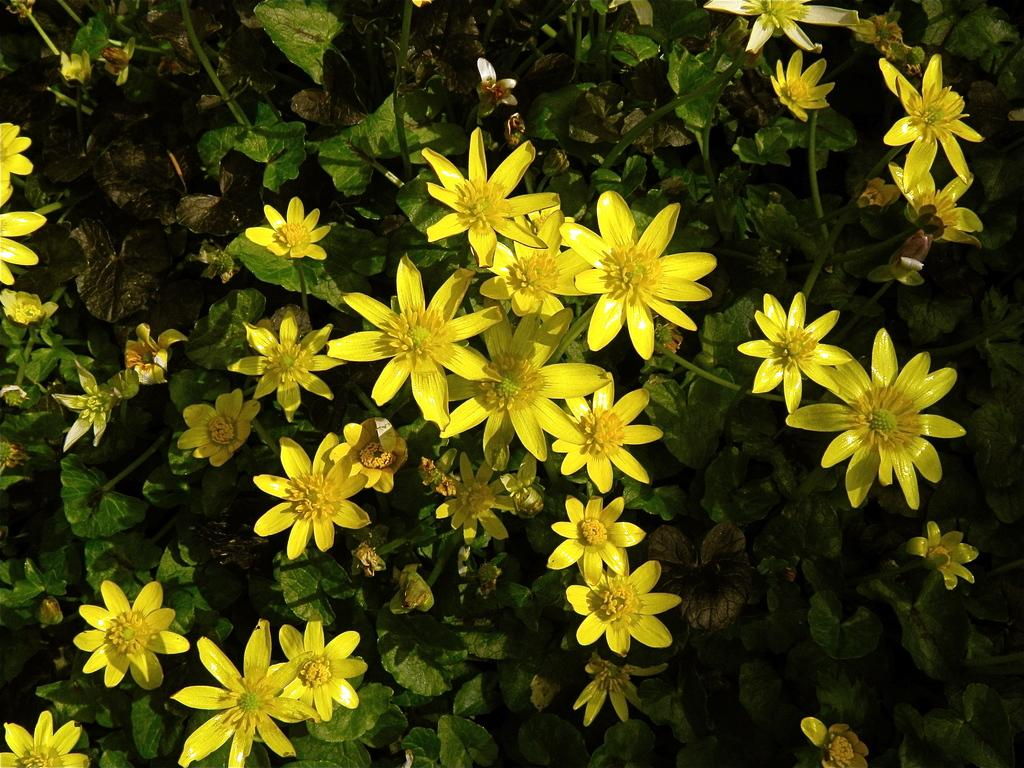What type of living organisms are present in the image? There are plants in the image. What specific feature can be observed on the plants? The plants have flowers. What color are the flowers? The flowers are in yellow color. What type of fowl can be seen in the image? There is no fowl present in the image; it features plants with yellow flowers. What is the beginner's level of gardening required to maintain these plants? The provided facts do not give information about the level of gardening required to maintain these plants, nor is there any indication of a beginner in the image. 